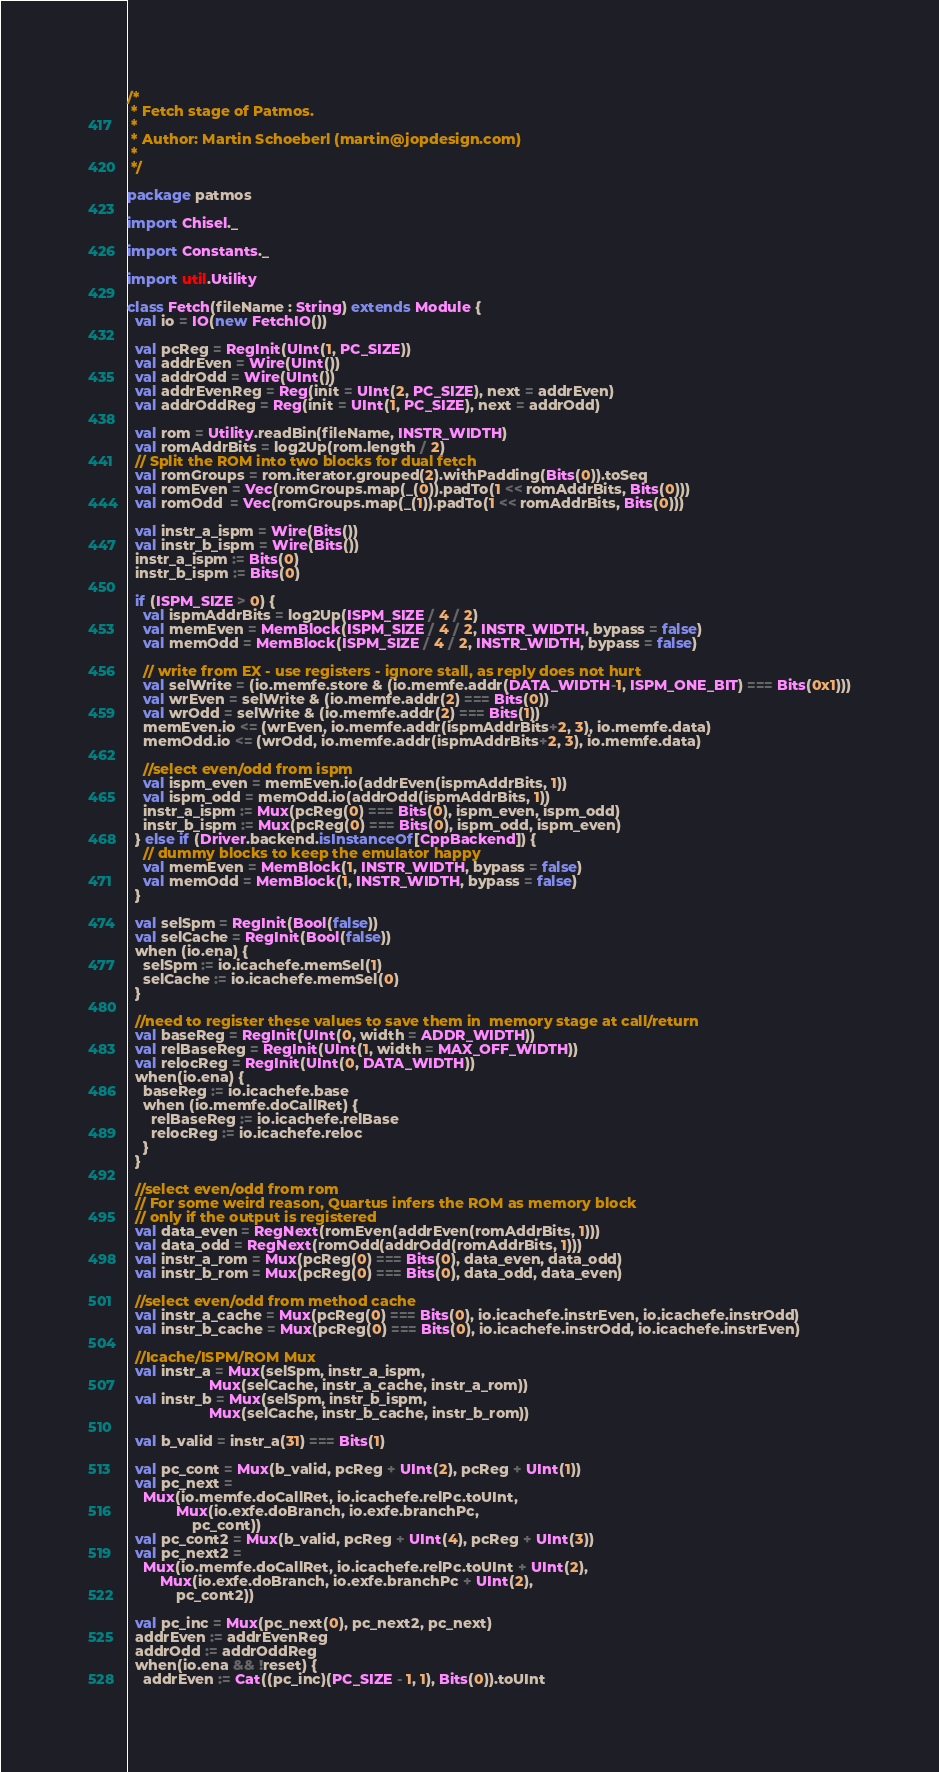Convert code to text. <code><loc_0><loc_0><loc_500><loc_500><_Scala_>/*
 * Fetch stage of Patmos.
 *
 * Author: Martin Schoeberl (martin@jopdesign.com)
 *
 */

package patmos

import Chisel._

import Constants._

import util.Utility

class Fetch(fileName : String) extends Module {
  val io = IO(new FetchIO())

  val pcReg = RegInit(UInt(1, PC_SIZE))
  val addrEven = Wire(UInt())
  val addrOdd = Wire(UInt())
  val addrEvenReg = Reg(init = UInt(2, PC_SIZE), next = addrEven)
  val addrOddReg = Reg(init = UInt(1, PC_SIZE), next = addrOdd)

  val rom = Utility.readBin(fileName, INSTR_WIDTH)
  val romAddrBits = log2Up(rom.length / 2)
  // Split the ROM into two blocks for dual fetch
  val romGroups = rom.iterator.grouped(2).withPadding(Bits(0)).toSeq
  val romEven = Vec(romGroups.map(_(0)).padTo(1 << romAddrBits, Bits(0)))
  val romOdd  = Vec(romGroups.map(_(1)).padTo(1 << romAddrBits, Bits(0)))

  val instr_a_ispm = Wire(Bits())
  val instr_b_ispm = Wire(Bits())
  instr_a_ispm := Bits(0)
  instr_b_ispm := Bits(0)
  
  if (ISPM_SIZE > 0) {
    val ispmAddrBits = log2Up(ISPM_SIZE / 4 / 2)
    val memEven = MemBlock(ISPM_SIZE / 4 / 2, INSTR_WIDTH, bypass = false)
    val memOdd = MemBlock(ISPM_SIZE / 4 / 2, INSTR_WIDTH, bypass = false)

    // write from EX - use registers - ignore stall, as reply does not hurt
    val selWrite = (io.memfe.store & (io.memfe.addr(DATA_WIDTH-1, ISPM_ONE_BIT) === Bits(0x1)))
    val wrEven = selWrite & (io.memfe.addr(2) === Bits(0))
    val wrOdd = selWrite & (io.memfe.addr(2) === Bits(1))
    memEven.io <= (wrEven, io.memfe.addr(ispmAddrBits+2, 3), io.memfe.data)
    memOdd.io <= (wrOdd, io.memfe.addr(ispmAddrBits+2, 3), io.memfe.data)

    //select even/odd from ispm
    val ispm_even = memEven.io(addrEven(ispmAddrBits, 1))
    val ispm_odd = memOdd.io(addrOdd(ispmAddrBits, 1))
    instr_a_ispm := Mux(pcReg(0) === Bits(0), ispm_even, ispm_odd)
    instr_b_ispm := Mux(pcReg(0) === Bits(0), ispm_odd, ispm_even)
  } else if (Driver.backend.isInstanceOf[CppBackend]) {
    // dummy blocks to keep the emulator happy
    val memEven = MemBlock(1, INSTR_WIDTH, bypass = false)
    val memOdd = MemBlock(1, INSTR_WIDTH, bypass = false)
  }

  val selSpm = RegInit(Bool(false))
  val selCache = RegInit(Bool(false))
  when (io.ena) {
    selSpm := io.icachefe.memSel(1)
    selCache := io.icachefe.memSel(0)
  }

  //need to register these values to save them in  memory stage at call/return
  val baseReg = RegInit(UInt(0, width = ADDR_WIDTH))
  val relBaseReg = RegInit(UInt(1, width = MAX_OFF_WIDTH))
  val relocReg = RegInit(UInt(0, DATA_WIDTH))
  when(io.ena) {
    baseReg := io.icachefe.base
    when (io.memfe.doCallRet) {
      relBaseReg := io.icachefe.relBase
      relocReg := io.icachefe.reloc
    }
  }

  //select even/odd from rom
  // For some weird reason, Quartus infers the ROM as memory block
  // only if the output is registered
  val data_even = RegNext(romEven(addrEven(romAddrBits, 1)))
  val data_odd = RegNext(romOdd(addrOdd(romAddrBits, 1)))
  val instr_a_rom = Mux(pcReg(0) === Bits(0), data_even, data_odd)
  val instr_b_rom = Mux(pcReg(0) === Bits(0), data_odd, data_even)

  //select even/odd from method cache
  val instr_a_cache = Mux(pcReg(0) === Bits(0), io.icachefe.instrEven, io.icachefe.instrOdd)
  val instr_b_cache = Mux(pcReg(0) === Bits(0), io.icachefe.instrOdd, io.icachefe.instrEven)

  //Icache/ISPM/ROM Mux
  val instr_a = Mux(selSpm, instr_a_ispm,
                    Mux(selCache, instr_a_cache, instr_a_rom))
  val instr_b = Mux(selSpm, instr_b_ispm,
                    Mux(selCache, instr_b_cache, instr_b_rom))

  val b_valid = instr_a(31) === Bits(1)

  val pc_cont = Mux(b_valid, pcReg + UInt(2), pcReg + UInt(1))
  val pc_next =
    Mux(io.memfe.doCallRet, io.icachefe.relPc.toUInt,
            Mux(io.exfe.doBranch, io.exfe.branchPc,
                pc_cont))
  val pc_cont2 = Mux(b_valid, pcReg + UInt(4), pcReg + UInt(3))
  val pc_next2 =
    Mux(io.memfe.doCallRet, io.icachefe.relPc.toUInt + UInt(2),
        Mux(io.exfe.doBranch, io.exfe.branchPc + UInt(2),
            pc_cont2))

  val pc_inc = Mux(pc_next(0), pc_next2, pc_next)
  addrEven := addrEvenReg
  addrOdd := addrOddReg
  when(io.ena && !reset) {
    addrEven := Cat((pc_inc)(PC_SIZE - 1, 1), Bits(0)).toUInt</code> 